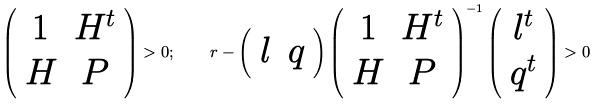<formula> <loc_0><loc_0><loc_500><loc_500>\left ( \begin{array} { c c } 1 & H ^ { t } \\ H & P \end{array} \right ) > 0 ; \quad r - \left ( \begin{array} { c c } l & q \end{array} \right ) \left ( \begin{array} { c c } 1 & H ^ { t } \\ H & P \end{array} \right ) ^ { - 1 } \left ( \begin{array} { c c } l ^ { t } \\ q ^ { t } \end{array} \right ) > 0</formula> 